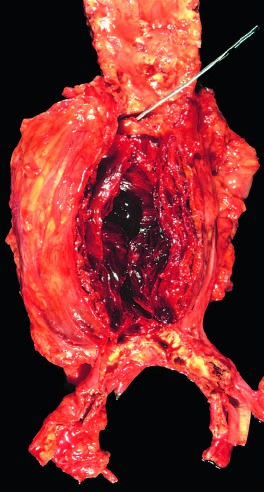s the areas of white chalky deposits filled by a large, layered thrombus?
Answer the question using a single word or phrase. No 